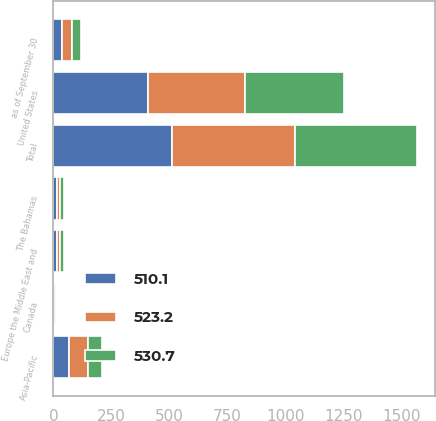<chart> <loc_0><loc_0><loc_500><loc_500><stacked_bar_chart><ecel><fcel>as of September 30<fcel>United States<fcel>Asia-Pacific<fcel>Europe the Middle East and<fcel>The Bahamas<fcel>Canada<fcel>Total<nl><fcel>530.7<fcel>39<fcel>428<fcel>62.9<fcel>14.9<fcel>14.3<fcel>3.1<fcel>523.2<nl><fcel>510.1<fcel>39<fcel>406.9<fcel>68.9<fcel>14.8<fcel>14.6<fcel>4.5<fcel>510.1<nl><fcel>523.2<fcel>39<fcel>417<fcel>78<fcel>13.8<fcel>15.1<fcel>5.9<fcel>530.7<nl></chart> 